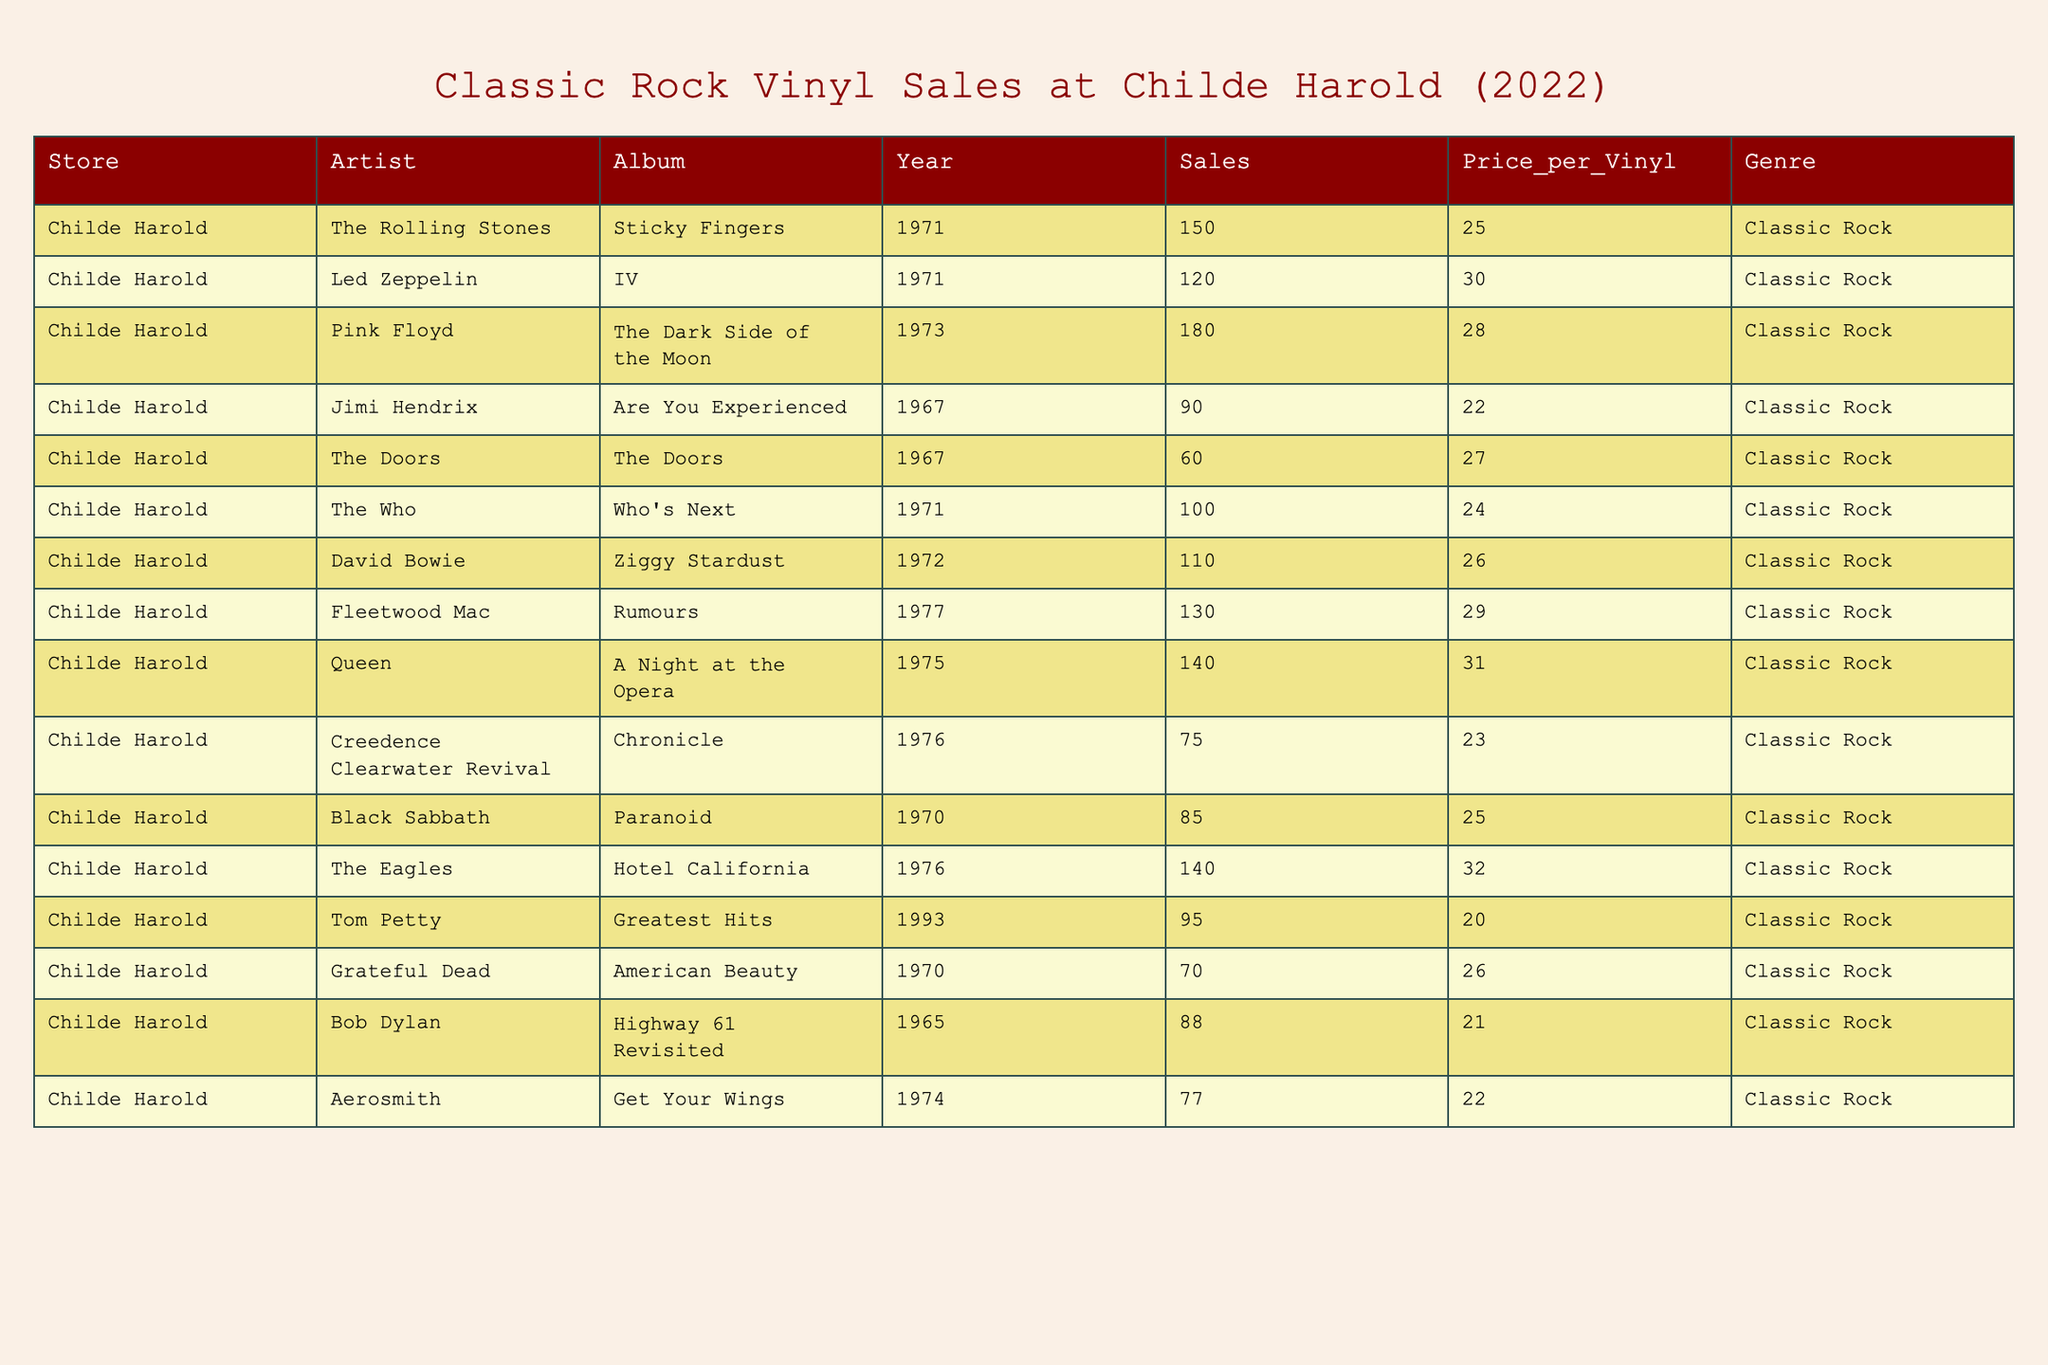What is the total number of vinyl records sold for Pink Floyd's album? The table shows that Pink Floyd's album "The Dark Side of the Moon" had 180 sales.
Answer: 180 Which album had the highest sales in the table? By comparing the sales figures, "The Dark Side of the Moon" by Pink Floyd has the highest sales at 180.
Answer: The Dark Side of the Moon What is the average price per vinyl for all the albums listed? The prices are: 25, 30, 28, 22, 27, 24, 26, 29, 31, 23, 25, 32, 20, 26, 21, 22. Summing them gives 408. There are 16 albums, so the average is 408 / 16 = 25.5.
Answer: 25.5 Did Led Zeppelin's IV sell more than the average sales of the albums in the table? Led Zeppelin's IV sold 120. The average sales needs to be calculated, which is (150 + 120 + 180 + 90 + 60 + 100 + 110 + 130 + 140 + 75 + 85 + 140 + 95 + 70 + 88 + 77) / 16 = 106.25. Since 120 > 106.25, the answer is yes.
Answer: Yes How much more did The Eagles' Hotel California sell compared to Creedence Clearwater Revival's Chronicle? The Eagles sold 140 and Creedence Clearwater Revival sold 75. The difference is 140 - 75 = 65.
Answer: 65 What percentage of total sales did Jimi Hendrix's album represent out of all sales? Jimi Hendrix sold 90. Total sales combine to 150 + 120 + 180 + 90 + 60 + 100 + 110 + 130 + 140 + 75 + 85 + 140 + 95 + 70 + 88 + 77 = 1,399. The percentage is (90 / 1399) * 100 ≈ 6.43%.
Answer: 6.43% Are there more albums from the 1970s than from other decades? The albums from the 1970s are: "Sticky Fingers," "IV," "The Dark Side of the Moon," "Who's Next," "Ziggy Stardust," "Rumours," "A Night at the Opera," "Chronicle," "Hotel California," and "Paranoid" — totaling 10. The 1960s have 3 and the 1990s have 1, meaning yes, there are more from the 1970s.
Answer: Yes What is the total revenue from Fleetwood Mac's Rumours? Fleetwood Mac's Rumours sold 130 at a price of 29 each. The revenue is 130 * 29 = 3,770.
Answer: 3770 